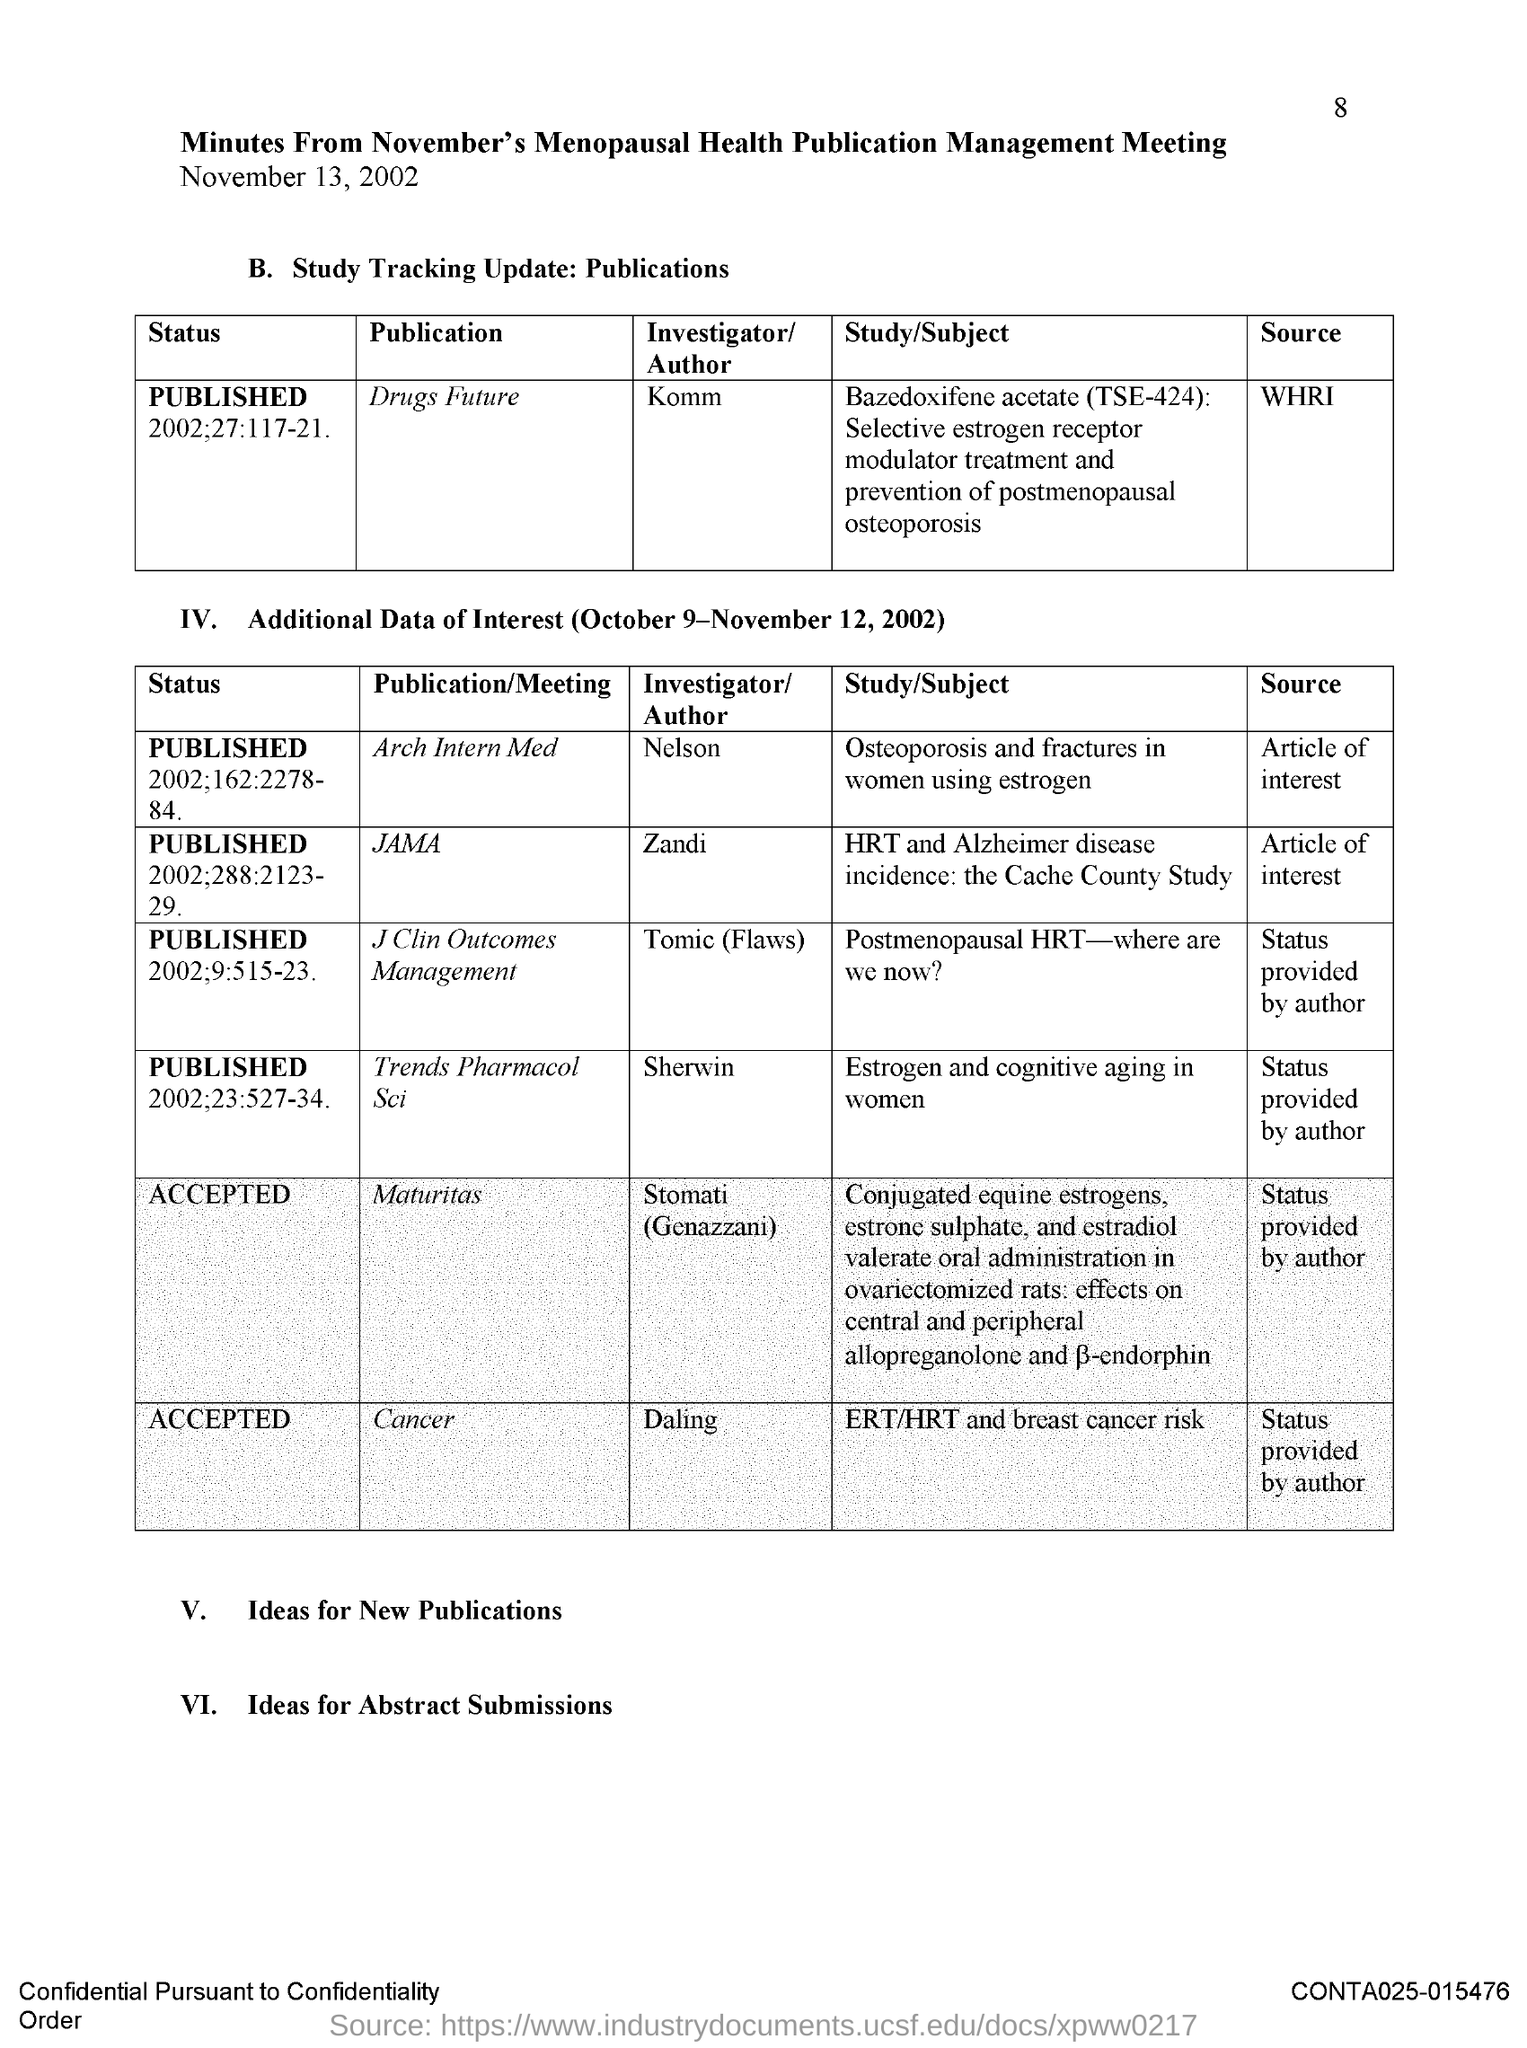What is the page number?
Provide a succinct answer. 8. Which meeting's minutes is this?
Make the answer very short. November's menopausal health publication management meeting. Who is the author of the publication "Drugs Future"?
Your answer should be very brief. Komm. Who is the author of the publication "JAMA"?
Your answer should be compact. Zandi. Daling is the author of which publication?
Offer a terse response. Cancer. What is the status of the publication "Cancer"?
Offer a very short reply. Accepted. What is the status of the publication "Maturitas"?
Your answer should be very brief. Accepted. 